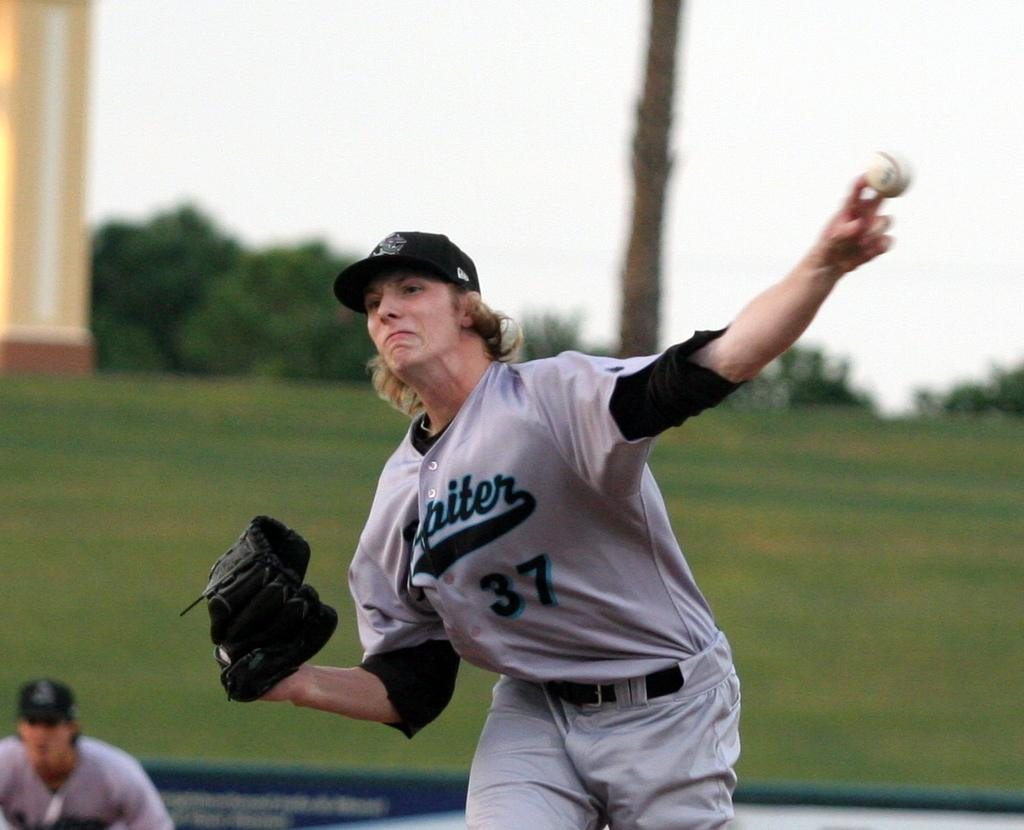Provide a one-sentence caption for the provided image. A person in a number 37 jersey is in the middle of throwing a baseball. 